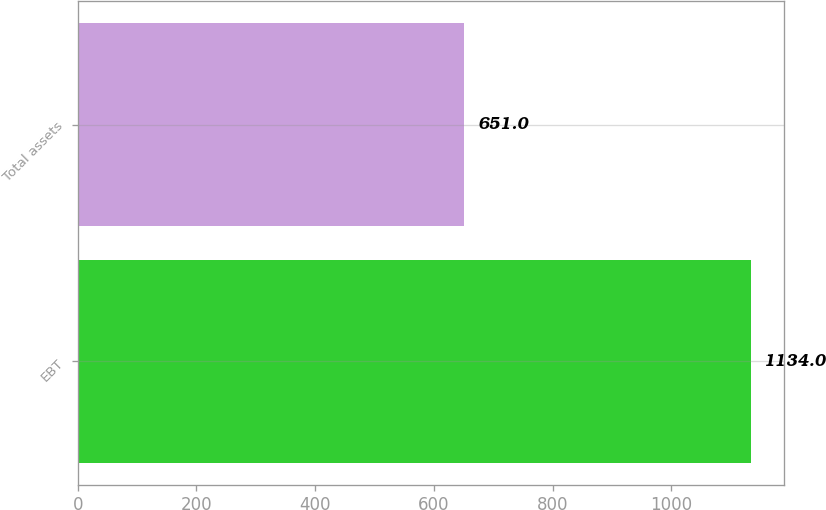Convert chart to OTSL. <chart><loc_0><loc_0><loc_500><loc_500><bar_chart><fcel>EBT<fcel>Total assets<nl><fcel>1134<fcel>651<nl></chart> 